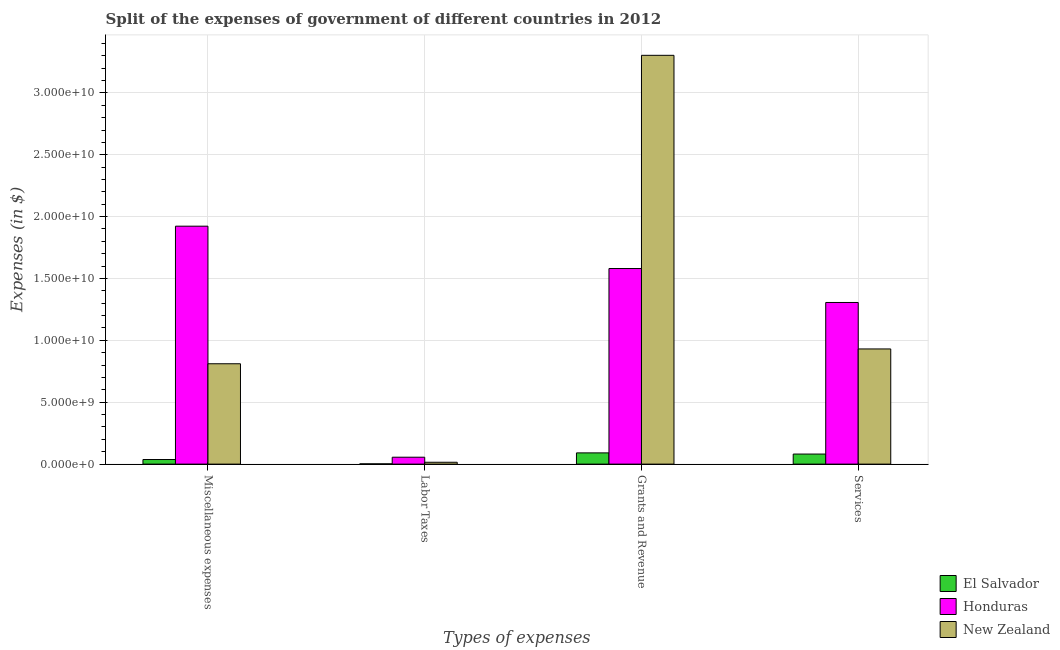Are the number of bars per tick equal to the number of legend labels?
Ensure brevity in your answer.  Yes. How many bars are there on the 3rd tick from the left?
Provide a succinct answer. 3. What is the label of the 1st group of bars from the left?
Keep it short and to the point. Miscellaneous expenses. What is the amount spent on services in El Salvador?
Offer a very short reply. 8.12e+08. Across all countries, what is the maximum amount spent on services?
Provide a succinct answer. 1.31e+1. Across all countries, what is the minimum amount spent on miscellaneous expenses?
Give a very brief answer. 3.70e+08. In which country was the amount spent on labor taxes maximum?
Offer a terse response. Honduras. In which country was the amount spent on miscellaneous expenses minimum?
Keep it short and to the point. El Salvador. What is the total amount spent on labor taxes in the graph?
Your answer should be very brief. 7.29e+08. What is the difference between the amount spent on miscellaneous expenses in New Zealand and that in El Salvador?
Make the answer very short. 7.74e+09. What is the difference between the amount spent on grants and revenue in El Salvador and the amount spent on labor taxes in New Zealand?
Your answer should be very brief. 7.58e+08. What is the average amount spent on services per country?
Your response must be concise. 7.73e+09. What is the difference between the amount spent on grants and revenue and amount spent on labor taxes in El Salvador?
Offer a very short reply. 8.87e+08. In how many countries, is the amount spent on miscellaneous expenses greater than 5000000000 $?
Your answer should be very brief. 2. What is the ratio of the amount spent on grants and revenue in New Zealand to that in El Salvador?
Offer a very short reply. 36.39. Is the amount spent on services in Honduras less than that in New Zealand?
Your answer should be compact. No. Is the difference between the amount spent on services in Honduras and El Salvador greater than the difference between the amount spent on grants and revenue in Honduras and El Salvador?
Your answer should be very brief. No. What is the difference between the highest and the second highest amount spent on services?
Give a very brief answer. 3.75e+09. What is the difference between the highest and the lowest amount spent on miscellaneous expenses?
Offer a terse response. 1.89e+1. Is the sum of the amount spent on labor taxes in El Salvador and New Zealand greater than the maximum amount spent on grants and revenue across all countries?
Provide a succinct answer. No. Is it the case that in every country, the sum of the amount spent on labor taxes and amount spent on services is greater than the sum of amount spent on miscellaneous expenses and amount spent on grants and revenue?
Offer a terse response. No. What does the 2nd bar from the left in Labor Taxes represents?
Give a very brief answer. Honduras. What does the 2nd bar from the right in Services represents?
Ensure brevity in your answer.  Honduras. How many bars are there?
Provide a short and direct response. 12. How many countries are there in the graph?
Offer a terse response. 3. Are the values on the major ticks of Y-axis written in scientific E-notation?
Offer a very short reply. Yes. Does the graph contain any zero values?
Offer a terse response. No. Where does the legend appear in the graph?
Provide a short and direct response. Bottom right. How many legend labels are there?
Offer a very short reply. 3. What is the title of the graph?
Offer a very short reply. Split of the expenses of government of different countries in 2012. Does "Bolivia" appear as one of the legend labels in the graph?
Your response must be concise. No. What is the label or title of the X-axis?
Your response must be concise. Types of expenses. What is the label or title of the Y-axis?
Your answer should be very brief. Expenses (in $). What is the Expenses (in $) of El Salvador in Miscellaneous expenses?
Provide a short and direct response. 3.70e+08. What is the Expenses (in $) of Honduras in Miscellaneous expenses?
Your answer should be compact. 1.92e+1. What is the Expenses (in $) in New Zealand in Miscellaneous expenses?
Keep it short and to the point. 8.11e+09. What is the Expenses (in $) in El Salvador in Labor Taxes?
Give a very brief answer. 2.09e+07. What is the Expenses (in $) in Honduras in Labor Taxes?
Ensure brevity in your answer.  5.58e+08. What is the Expenses (in $) of New Zealand in Labor Taxes?
Provide a succinct answer. 1.50e+08. What is the Expenses (in $) of El Salvador in Grants and Revenue?
Keep it short and to the point. 9.08e+08. What is the Expenses (in $) in Honduras in Grants and Revenue?
Provide a short and direct response. 1.58e+1. What is the Expenses (in $) in New Zealand in Grants and Revenue?
Provide a short and direct response. 3.30e+1. What is the Expenses (in $) of El Salvador in Services?
Your answer should be compact. 8.12e+08. What is the Expenses (in $) of Honduras in Services?
Provide a short and direct response. 1.31e+1. What is the Expenses (in $) of New Zealand in Services?
Provide a short and direct response. 9.31e+09. Across all Types of expenses, what is the maximum Expenses (in $) of El Salvador?
Make the answer very short. 9.08e+08. Across all Types of expenses, what is the maximum Expenses (in $) in Honduras?
Offer a terse response. 1.92e+1. Across all Types of expenses, what is the maximum Expenses (in $) in New Zealand?
Your answer should be compact. 3.30e+1. Across all Types of expenses, what is the minimum Expenses (in $) of El Salvador?
Offer a very short reply. 2.09e+07. Across all Types of expenses, what is the minimum Expenses (in $) of Honduras?
Keep it short and to the point. 5.58e+08. Across all Types of expenses, what is the minimum Expenses (in $) of New Zealand?
Offer a terse response. 1.50e+08. What is the total Expenses (in $) in El Salvador in the graph?
Provide a succinct answer. 2.11e+09. What is the total Expenses (in $) of Honduras in the graph?
Ensure brevity in your answer.  4.87e+1. What is the total Expenses (in $) of New Zealand in the graph?
Your answer should be very brief. 5.06e+1. What is the difference between the Expenses (in $) in El Salvador in Miscellaneous expenses and that in Labor Taxes?
Make the answer very short. 3.50e+08. What is the difference between the Expenses (in $) in Honduras in Miscellaneous expenses and that in Labor Taxes?
Provide a succinct answer. 1.87e+1. What is the difference between the Expenses (in $) of New Zealand in Miscellaneous expenses and that in Labor Taxes?
Your response must be concise. 7.96e+09. What is the difference between the Expenses (in $) in El Salvador in Miscellaneous expenses and that in Grants and Revenue?
Your response must be concise. -5.37e+08. What is the difference between the Expenses (in $) in Honduras in Miscellaneous expenses and that in Grants and Revenue?
Provide a succinct answer. 3.42e+09. What is the difference between the Expenses (in $) in New Zealand in Miscellaneous expenses and that in Grants and Revenue?
Offer a very short reply. -2.49e+1. What is the difference between the Expenses (in $) in El Salvador in Miscellaneous expenses and that in Services?
Your answer should be compact. -4.42e+08. What is the difference between the Expenses (in $) of Honduras in Miscellaneous expenses and that in Services?
Provide a succinct answer. 6.17e+09. What is the difference between the Expenses (in $) in New Zealand in Miscellaneous expenses and that in Services?
Give a very brief answer. -1.20e+09. What is the difference between the Expenses (in $) in El Salvador in Labor Taxes and that in Grants and Revenue?
Your answer should be very brief. -8.87e+08. What is the difference between the Expenses (in $) of Honduras in Labor Taxes and that in Grants and Revenue?
Provide a succinct answer. -1.52e+1. What is the difference between the Expenses (in $) in New Zealand in Labor Taxes and that in Grants and Revenue?
Keep it short and to the point. -3.29e+1. What is the difference between the Expenses (in $) in El Salvador in Labor Taxes and that in Services?
Keep it short and to the point. -7.92e+08. What is the difference between the Expenses (in $) in Honduras in Labor Taxes and that in Services?
Ensure brevity in your answer.  -1.25e+1. What is the difference between the Expenses (in $) of New Zealand in Labor Taxes and that in Services?
Offer a terse response. -9.16e+09. What is the difference between the Expenses (in $) of El Salvador in Grants and Revenue and that in Services?
Keep it short and to the point. 9.54e+07. What is the difference between the Expenses (in $) in Honduras in Grants and Revenue and that in Services?
Offer a very short reply. 2.74e+09. What is the difference between the Expenses (in $) in New Zealand in Grants and Revenue and that in Services?
Offer a terse response. 2.37e+1. What is the difference between the Expenses (in $) in El Salvador in Miscellaneous expenses and the Expenses (in $) in Honduras in Labor Taxes?
Give a very brief answer. -1.87e+08. What is the difference between the Expenses (in $) of El Salvador in Miscellaneous expenses and the Expenses (in $) of New Zealand in Labor Taxes?
Ensure brevity in your answer.  2.20e+08. What is the difference between the Expenses (in $) in Honduras in Miscellaneous expenses and the Expenses (in $) in New Zealand in Labor Taxes?
Provide a succinct answer. 1.91e+1. What is the difference between the Expenses (in $) of El Salvador in Miscellaneous expenses and the Expenses (in $) of Honduras in Grants and Revenue?
Your response must be concise. -1.54e+1. What is the difference between the Expenses (in $) of El Salvador in Miscellaneous expenses and the Expenses (in $) of New Zealand in Grants and Revenue?
Provide a short and direct response. -3.27e+1. What is the difference between the Expenses (in $) of Honduras in Miscellaneous expenses and the Expenses (in $) of New Zealand in Grants and Revenue?
Offer a very short reply. -1.38e+1. What is the difference between the Expenses (in $) in El Salvador in Miscellaneous expenses and the Expenses (in $) in Honduras in Services?
Keep it short and to the point. -1.27e+1. What is the difference between the Expenses (in $) in El Salvador in Miscellaneous expenses and the Expenses (in $) in New Zealand in Services?
Offer a terse response. -8.94e+09. What is the difference between the Expenses (in $) of Honduras in Miscellaneous expenses and the Expenses (in $) of New Zealand in Services?
Offer a terse response. 9.92e+09. What is the difference between the Expenses (in $) of El Salvador in Labor Taxes and the Expenses (in $) of Honduras in Grants and Revenue?
Make the answer very short. -1.58e+1. What is the difference between the Expenses (in $) of El Salvador in Labor Taxes and the Expenses (in $) of New Zealand in Grants and Revenue?
Make the answer very short. -3.30e+1. What is the difference between the Expenses (in $) in Honduras in Labor Taxes and the Expenses (in $) in New Zealand in Grants and Revenue?
Provide a succinct answer. -3.25e+1. What is the difference between the Expenses (in $) of El Salvador in Labor Taxes and the Expenses (in $) of Honduras in Services?
Keep it short and to the point. -1.30e+1. What is the difference between the Expenses (in $) in El Salvador in Labor Taxes and the Expenses (in $) in New Zealand in Services?
Your response must be concise. -9.29e+09. What is the difference between the Expenses (in $) of Honduras in Labor Taxes and the Expenses (in $) of New Zealand in Services?
Provide a short and direct response. -8.75e+09. What is the difference between the Expenses (in $) of El Salvador in Grants and Revenue and the Expenses (in $) of Honduras in Services?
Provide a short and direct response. -1.22e+1. What is the difference between the Expenses (in $) in El Salvador in Grants and Revenue and the Expenses (in $) in New Zealand in Services?
Offer a terse response. -8.40e+09. What is the difference between the Expenses (in $) of Honduras in Grants and Revenue and the Expenses (in $) of New Zealand in Services?
Your answer should be very brief. 6.50e+09. What is the average Expenses (in $) of El Salvador per Types of expenses?
Keep it short and to the point. 5.28e+08. What is the average Expenses (in $) in Honduras per Types of expenses?
Offer a terse response. 1.22e+1. What is the average Expenses (in $) of New Zealand per Types of expenses?
Your response must be concise. 1.27e+1. What is the difference between the Expenses (in $) of El Salvador and Expenses (in $) of Honduras in Miscellaneous expenses?
Your answer should be very brief. -1.89e+1. What is the difference between the Expenses (in $) in El Salvador and Expenses (in $) in New Zealand in Miscellaneous expenses?
Offer a very short reply. -7.74e+09. What is the difference between the Expenses (in $) of Honduras and Expenses (in $) of New Zealand in Miscellaneous expenses?
Give a very brief answer. 1.11e+1. What is the difference between the Expenses (in $) in El Salvador and Expenses (in $) in Honduras in Labor Taxes?
Provide a short and direct response. -5.37e+08. What is the difference between the Expenses (in $) of El Salvador and Expenses (in $) of New Zealand in Labor Taxes?
Offer a very short reply. -1.29e+08. What is the difference between the Expenses (in $) in Honduras and Expenses (in $) in New Zealand in Labor Taxes?
Make the answer very short. 4.08e+08. What is the difference between the Expenses (in $) in El Salvador and Expenses (in $) in Honduras in Grants and Revenue?
Your answer should be compact. -1.49e+1. What is the difference between the Expenses (in $) in El Salvador and Expenses (in $) in New Zealand in Grants and Revenue?
Keep it short and to the point. -3.21e+1. What is the difference between the Expenses (in $) of Honduras and Expenses (in $) of New Zealand in Grants and Revenue?
Make the answer very short. -1.72e+1. What is the difference between the Expenses (in $) in El Salvador and Expenses (in $) in Honduras in Services?
Your answer should be very brief. -1.22e+1. What is the difference between the Expenses (in $) in El Salvador and Expenses (in $) in New Zealand in Services?
Your answer should be compact. -8.49e+09. What is the difference between the Expenses (in $) in Honduras and Expenses (in $) in New Zealand in Services?
Provide a succinct answer. 3.75e+09. What is the ratio of the Expenses (in $) in El Salvador in Miscellaneous expenses to that in Labor Taxes?
Offer a very short reply. 17.73. What is the ratio of the Expenses (in $) in Honduras in Miscellaneous expenses to that in Labor Taxes?
Offer a terse response. 34.47. What is the ratio of the Expenses (in $) in New Zealand in Miscellaneous expenses to that in Labor Taxes?
Offer a terse response. 54.07. What is the ratio of the Expenses (in $) of El Salvador in Miscellaneous expenses to that in Grants and Revenue?
Your response must be concise. 0.41. What is the ratio of the Expenses (in $) in Honduras in Miscellaneous expenses to that in Grants and Revenue?
Give a very brief answer. 1.22. What is the ratio of the Expenses (in $) in New Zealand in Miscellaneous expenses to that in Grants and Revenue?
Offer a very short reply. 0.25. What is the ratio of the Expenses (in $) in El Salvador in Miscellaneous expenses to that in Services?
Provide a succinct answer. 0.46. What is the ratio of the Expenses (in $) of Honduras in Miscellaneous expenses to that in Services?
Your answer should be compact. 1.47. What is the ratio of the Expenses (in $) of New Zealand in Miscellaneous expenses to that in Services?
Offer a very short reply. 0.87. What is the ratio of the Expenses (in $) of El Salvador in Labor Taxes to that in Grants and Revenue?
Keep it short and to the point. 0.02. What is the ratio of the Expenses (in $) in Honduras in Labor Taxes to that in Grants and Revenue?
Provide a succinct answer. 0.04. What is the ratio of the Expenses (in $) in New Zealand in Labor Taxes to that in Grants and Revenue?
Keep it short and to the point. 0. What is the ratio of the Expenses (in $) of El Salvador in Labor Taxes to that in Services?
Offer a very short reply. 0.03. What is the ratio of the Expenses (in $) of Honduras in Labor Taxes to that in Services?
Provide a short and direct response. 0.04. What is the ratio of the Expenses (in $) in New Zealand in Labor Taxes to that in Services?
Provide a short and direct response. 0.02. What is the ratio of the Expenses (in $) of El Salvador in Grants and Revenue to that in Services?
Your answer should be very brief. 1.12. What is the ratio of the Expenses (in $) in Honduras in Grants and Revenue to that in Services?
Keep it short and to the point. 1.21. What is the ratio of the Expenses (in $) in New Zealand in Grants and Revenue to that in Services?
Give a very brief answer. 3.55. What is the difference between the highest and the second highest Expenses (in $) of El Salvador?
Your response must be concise. 9.54e+07. What is the difference between the highest and the second highest Expenses (in $) of Honduras?
Provide a short and direct response. 3.42e+09. What is the difference between the highest and the second highest Expenses (in $) in New Zealand?
Your answer should be very brief. 2.37e+1. What is the difference between the highest and the lowest Expenses (in $) in El Salvador?
Your answer should be very brief. 8.87e+08. What is the difference between the highest and the lowest Expenses (in $) in Honduras?
Give a very brief answer. 1.87e+1. What is the difference between the highest and the lowest Expenses (in $) of New Zealand?
Keep it short and to the point. 3.29e+1. 